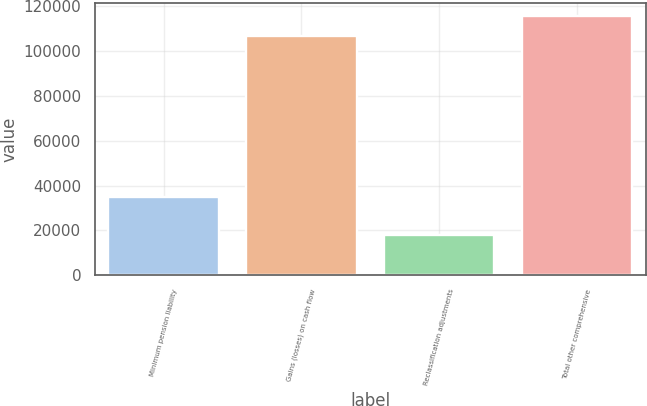Convert chart to OTSL. <chart><loc_0><loc_0><loc_500><loc_500><bar_chart><fcel>Minimum pension liability<fcel>Gains (losses) on cash flow<fcel>Reclassification adjustments<fcel>Total other comprehensive<nl><fcel>34899<fcel>106748<fcel>17914<fcel>115677<nl></chart> 